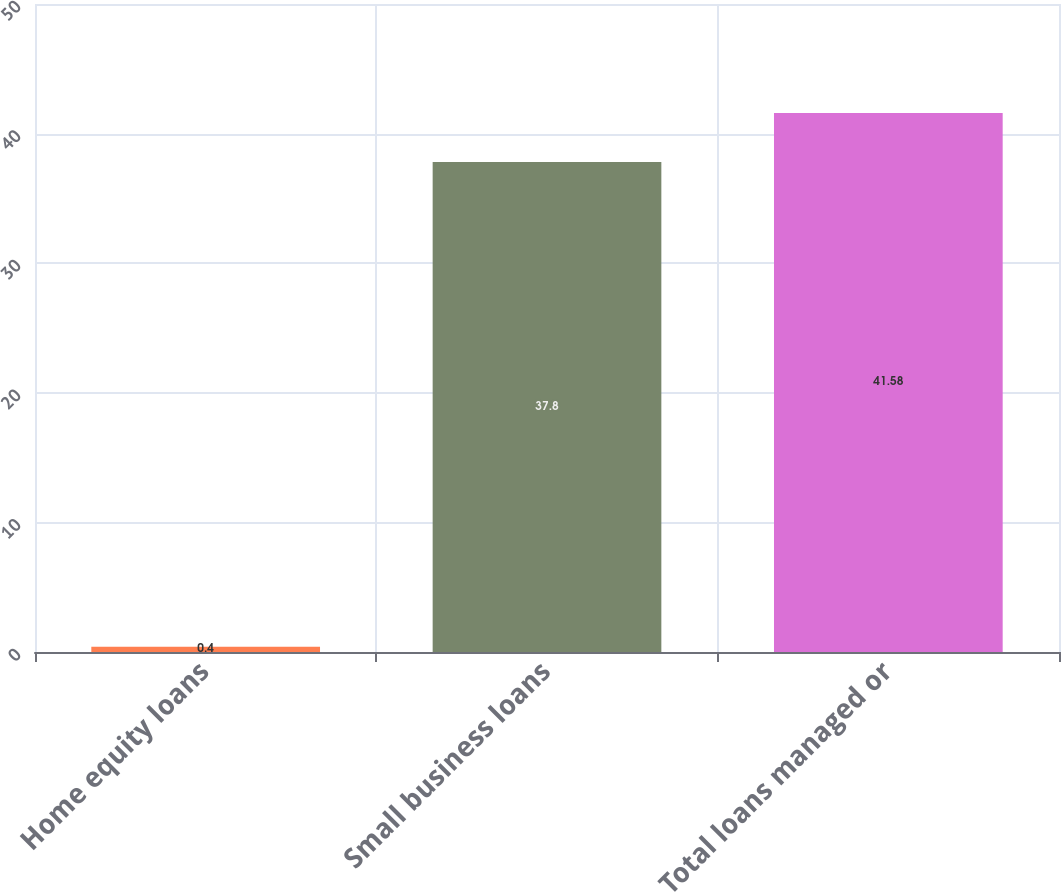<chart> <loc_0><loc_0><loc_500><loc_500><bar_chart><fcel>Home equity loans<fcel>Small business loans<fcel>Total loans managed or<nl><fcel>0.4<fcel>37.8<fcel>41.58<nl></chart> 